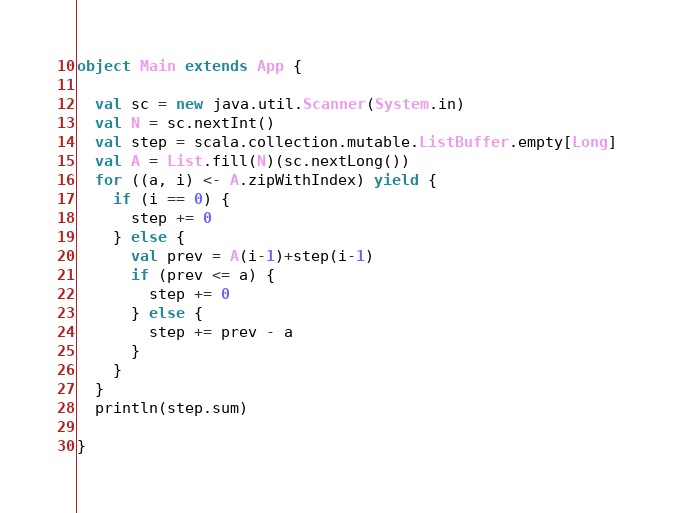Convert code to text. <code><loc_0><loc_0><loc_500><loc_500><_Scala_>
object Main extends App {
  
  val sc = new java.util.Scanner(System.in)
  val N = sc.nextInt()
  val step = scala.collection.mutable.ListBuffer.empty[Long]
  val A = List.fill(N)(sc.nextLong())
  for ((a, i) <- A.zipWithIndex) yield {
    if (i == 0) {
      step += 0
    } else {
      val prev = A(i-1)+step(i-1)
      if (prev <= a) {
        step += 0
      } else {
        step += prev - a
      }
    }
  }
  println(step.sum)  

}
</code> 